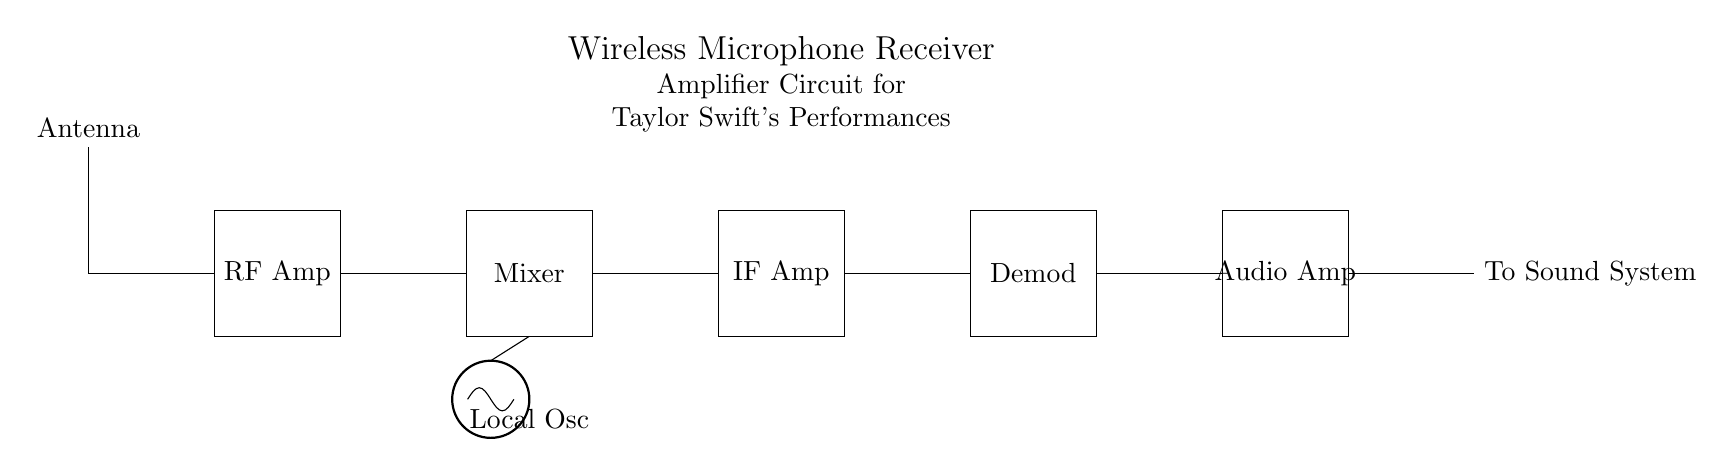What is the first component in the circuit? The first component displayed in the diagram from left to right is the antenna, used to capture the radio frequency signals.
Answer: Antenna What type of amplifier is present after the antenna? Following the antenna in the circuit diagram is the RF amplifier, which amplifies the received radio frequency signal.
Answer: RF Amp What does the Local Oscillator do in this circuit? The Local Oscillator generates a signal that mixes with the incoming RF from the antenna, allowing for frequency conversion and signal processing.
Answer: Frequency conversion How many amplifiers are in the circuit? There are three amplifiers: RF Amp, IF Amp, and Audio Amp, each serving a specific stage of amplification in the signal processing.
Answer: Three What is the purpose of the Demodulator? The Demodulator extracts the original audio signal from the modulated RF signal after amplification, facilitating audio playback.
Answer: Extract audio What is the audio output labeled as? The output of the Audio Amplifier is labeled as "To Sound System," indicating that the audio signal is directed to the sound system for amplification.
Answer: To Sound System How does the Mixer contribute to the circuit? The Mixer combines the input RF signal with the Local Oscillator signal, aiding in translating the frequency to an intermediate frequency suitable for further amplification and demodulation.
Answer: Frequency translation 